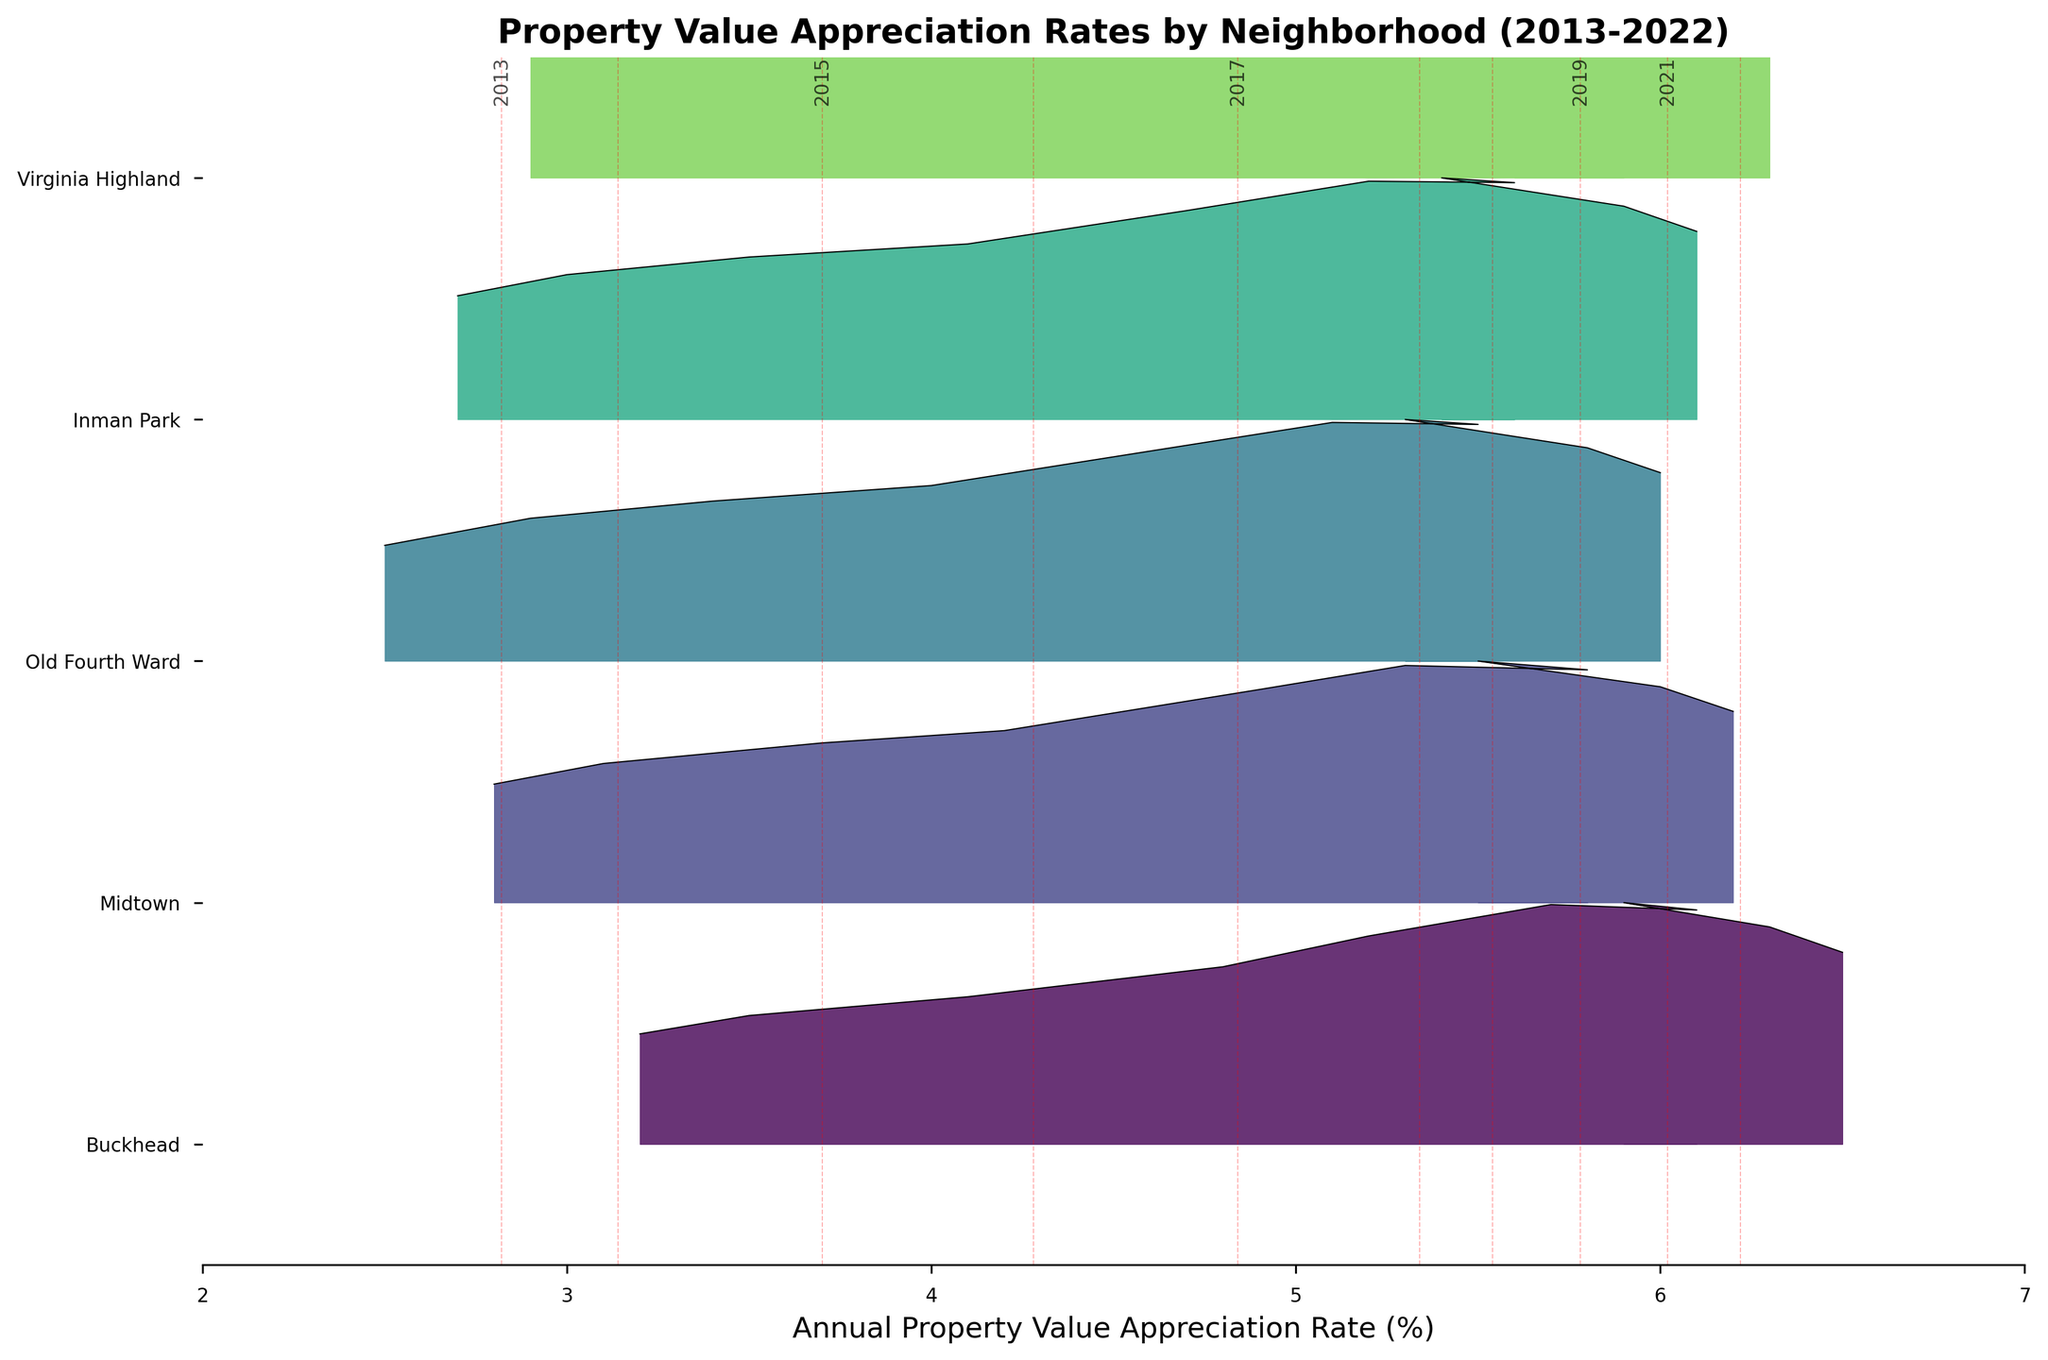What's the title of this plot? The title of the plot is usually at the top of the chart, summarizing the visualized data. The title here is "Property Value Appreciation Rates by Neighborhood (2013-2022)"
Answer: Property Value Appreciation Rates by Neighborhood (2013-2022) Which neighborhood has the highest appreciation rate in 2022? By looking at the furthest right point for each neighborhood, you can find that Buckhead has the highest value, around 6.5%
Answer: Buckhead Are there any neighborhoods with decreasing rates from 2020 to 2022? By examining the appreciation rates from 2020 to 2022 for each neighborhood, it appears that none of the neighborhoods show a decrease. The rates either remain constant or increase.
Answer: No Which neighborhoods have a consistently increasing appreciation rate over the years? By tracing the ridgeline for each neighborhood from left to right (2013 to 2022), neighborhoods like Buckhead, Midtown, Old Fourth Ward, Inman Park, and Virginia Highland show a consistent increase.
Answer: Buckhead, Midtown, Old Fourth Ward, Inman Park, Virginia Highland Which neighborhood had the lowest appreciation rate in 2013? By identifying the lowest point on the left side of the plot, Old Fourth Ward has the lowest appreciation rate in 2013, around 2.5%
Answer: Old Fourth Ward What is the average appreciation rate for Buckhead from 2013 to 2022? Adding the appreciation rates for Buckhead from each year (3.2 + 3.5 + 4.1 + 4.8 + 5.2 + 5.7 + 6.1 + 5.9 + 6.3 + 6.5) and dividing by 10 gives the average rate.
Answer: 5.13% Comparing Buckhead and Midtown, which neighborhood had a higher rate in 2019? By looking at the year 2019 on both ridgelines, Buckhead had a rate of 6.1%, while Midtown had 5.8%. Thus, Buckhead's rate is higher.
Answer: Buckhead Which neighborhood had the highest rate in 2021? By observing the intersection of rates for the year 2021, Buckhead’s rate is highest at 6.3%.
Answer: Buckhead What is the range (difference between the highest and lowest rate) of the appreciation rates for Virginia Highland in the plot? The highest rate for Virginia Highland is around 6.3% in 2022, and the lowest is around 2.9% in 2013. The range is 6.3 - 2.9.
Answer: 3.4% In which year did Midtown first surpass a 5% appreciation rate? By following the plot from left to right, Midtown surpasses a 5% rate in 2018.
Answer: 2018 